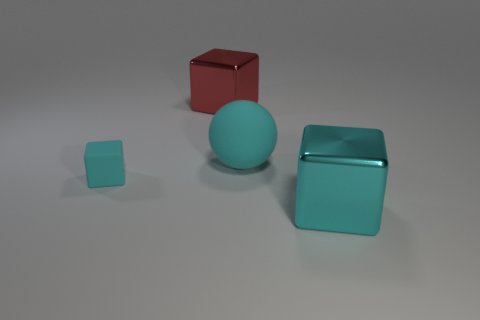Is the number of big red objects that are behind the cyan matte block greater than the number of green metal cylinders?
Provide a succinct answer. Yes. There is a object that is left of the cyan metallic cube and in front of the cyan rubber sphere; what material is it made of?
Your answer should be very brief. Rubber. Is the color of the shiny block on the right side of the big matte thing the same as the cube left of the big red metallic thing?
Your response must be concise. Yes. How many other things are the same size as the cyan matte cube?
Provide a succinct answer. 0. There is a cyan rubber object right of the cyan rubber thing that is left of the large red metal thing; are there any large metallic blocks that are on the right side of it?
Give a very brief answer. Yes. Is the large block that is right of the big red metallic thing made of the same material as the red cube?
Provide a succinct answer. Yes. The matte object that is the same shape as the large red metal thing is what color?
Offer a very short reply. Cyan. Is there anything else that is the same shape as the big rubber object?
Your answer should be compact. No. Is the number of small cyan matte cubes in front of the large cyan block the same as the number of green rubber spheres?
Offer a very short reply. Yes. Are there any tiny cyan rubber blocks right of the large cyan metallic block?
Offer a terse response. No. 